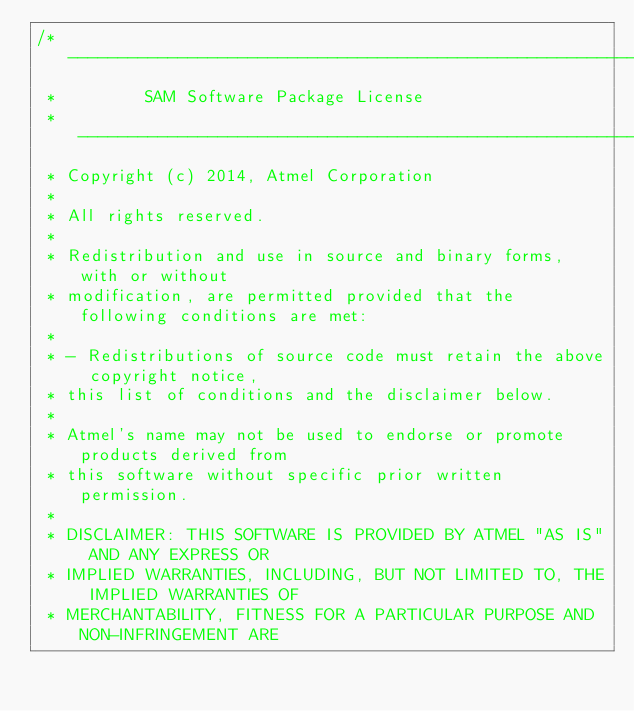Convert code to text. <code><loc_0><loc_0><loc_500><loc_500><_C_>/* ----------------------------------------------------------------------------
 *         SAM Software Package License
 * ----------------------------------------------------------------------------
 * Copyright (c) 2014, Atmel Corporation
 *
 * All rights reserved.
 *
 * Redistribution and use in source and binary forms, with or without
 * modification, are permitted provided that the following conditions are met:
 *
 * - Redistributions of source code must retain the above copyright notice,
 * this list of conditions and the disclaimer below.
 *
 * Atmel's name may not be used to endorse or promote products derived from
 * this software without specific prior written permission.
 *
 * DISCLAIMER: THIS SOFTWARE IS PROVIDED BY ATMEL "AS IS" AND ANY EXPRESS OR
 * IMPLIED WARRANTIES, INCLUDING, BUT NOT LIMITED TO, THE IMPLIED WARRANTIES OF
 * MERCHANTABILITY, FITNESS FOR A PARTICULAR PURPOSE AND NON-INFRINGEMENT ARE</code> 